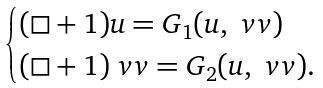Convert formula to latex. <formula><loc_0><loc_0><loc_500><loc_500>\begin{cases} ( \square + 1 ) u = G _ { 1 } ( u , \ v v ) \\ ( \square + 1 ) \ v v = G _ { 2 } ( u , \ v v ) . \end{cases}</formula> 